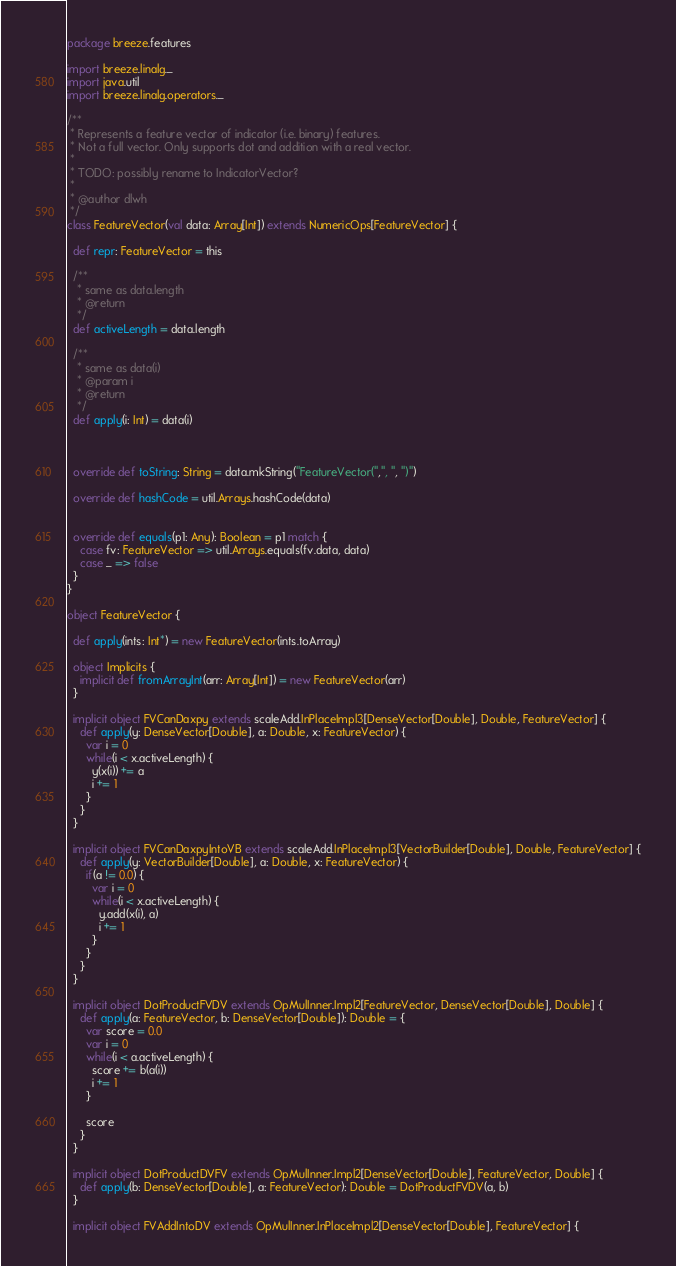Convert code to text. <code><loc_0><loc_0><loc_500><loc_500><_Scala_>package breeze.features

import breeze.linalg._
import java.util
import breeze.linalg.operators._

/**
 * Represents a feature vector of indicator (i.e. binary) features.
 * Not a full vector. Only supports dot and addition with a real vector.
 *
 * TODO: possibly rename to IndicatorVector?
 *
 * @author dlwh
 */
class FeatureVector(val data: Array[Int]) extends NumericOps[FeatureVector] {

  def repr: FeatureVector = this

  /**
   * same as data.length
   * @return
   */
  def activeLength = data.length

  /**
   * same as data(i)
   * @param i
   * @return
   */
  def apply(i: Int) = data(i)



  override def toString: String = data.mkString("FeatureVector(",", ", ")")

  override def hashCode = util.Arrays.hashCode(data)


  override def equals(p1: Any): Boolean = p1 match {
    case fv: FeatureVector => util.Arrays.equals(fv.data, data)
    case _ => false
  }
}

object FeatureVector {

  def apply(ints: Int*) = new FeatureVector(ints.toArray)

  object Implicits {
    implicit def fromArrayInt(arr: Array[Int]) = new FeatureVector(arr)
  }

  implicit object FVCanDaxpy extends scaleAdd.InPlaceImpl3[DenseVector[Double], Double, FeatureVector] {
    def apply(y: DenseVector[Double], a: Double, x: FeatureVector) {
      var i = 0
      while(i < x.activeLength) {
        y(x(i)) += a
        i += 1
      }
    }
  }

  implicit object FVCanDaxpyIntoVB extends scaleAdd.InPlaceImpl3[VectorBuilder[Double], Double, FeatureVector] {
    def apply(y: VectorBuilder[Double], a: Double, x: FeatureVector) {
      if(a != 0.0) {
        var i = 0
        while(i < x.activeLength) {
          y.add(x(i), a)
          i += 1
        }
      }
    }
  }

  implicit object DotProductFVDV extends OpMulInner.Impl2[FeatureVector, DenseVector[Double], Double] {
    def apply(a: FeatureVector, b: DenseVector[Double]): Double = {
      var score = 0.0
      var i = 0
      while(i < a.activeLength) {
        score += b(a(i))
        i += 1
      }

      score
    }
  }

  implicit object DotProductDVFV extends OpMulInner.Impl2[DenseVector[Double], FeatureVector, Double] {
    def apply(b: DenseVector[Double], a: FeatureVector): Double = DotProductFVDV(a, b)
  }

  implicit object FVAddIntoDV extends OpMulInner.InPlaceImpl2[DenseVector[Double], FeatureVector] {</code> 